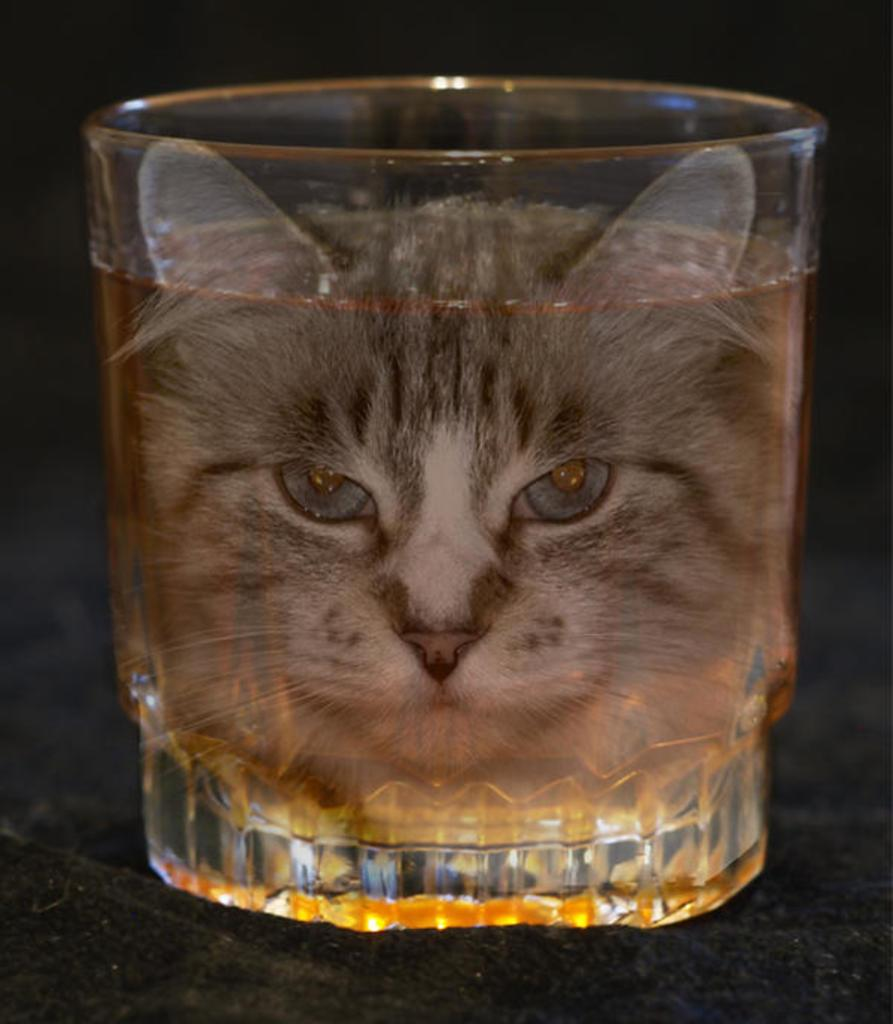What is inside the glass in the image? There is a drink in the glass. What design is on the glass? The glass has a cat face on it. What trick does the cat face on the glass perform in the image? There is no trick performed by the cat face on the glass in the image; it is simply a design on the glass. 